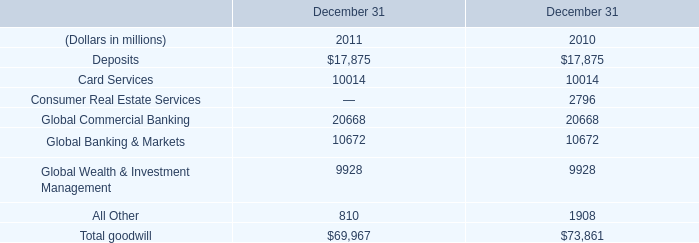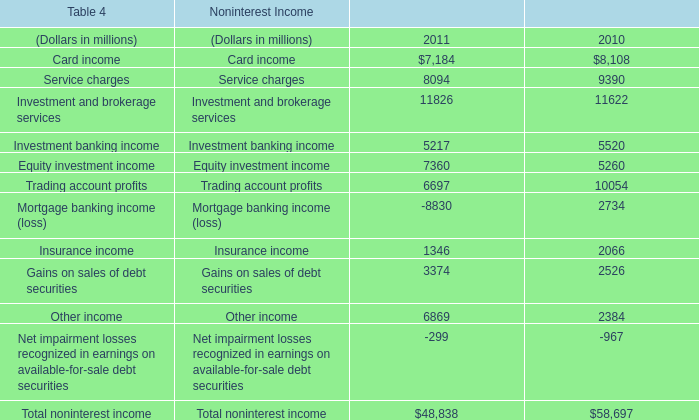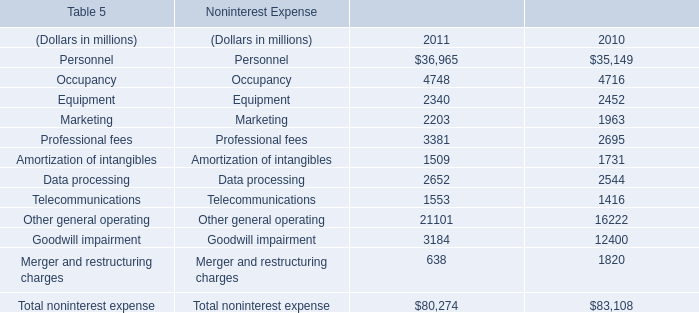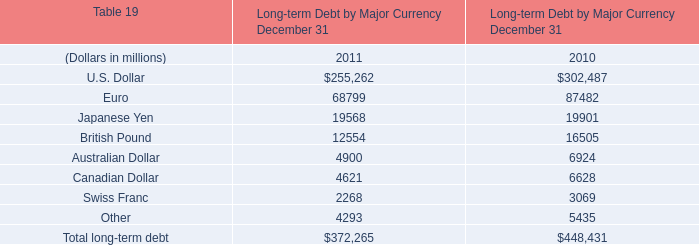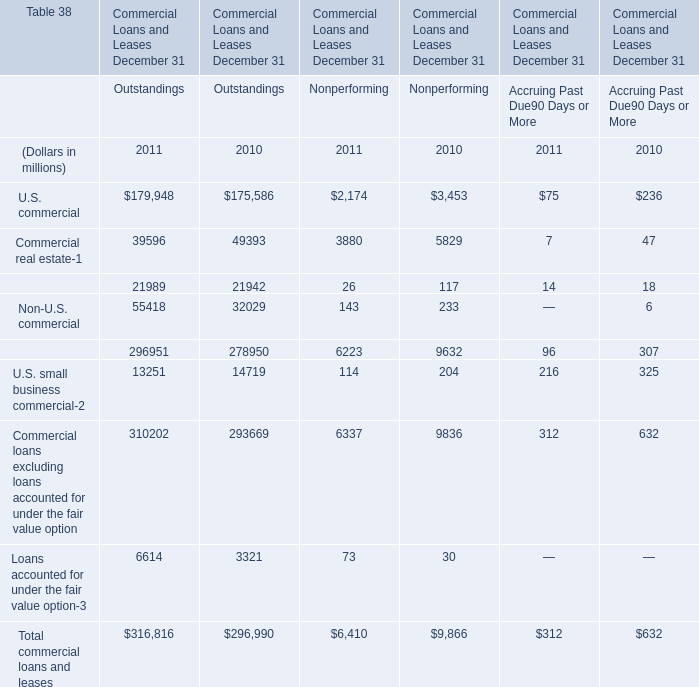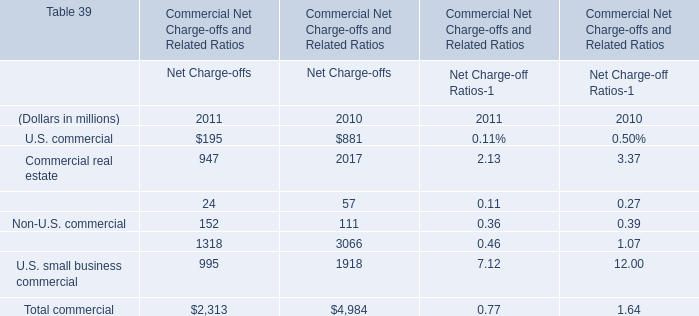If Non-U.S. commercial in terms of Net Charge-offs develops with the same growth rate in 2011, what will it reach in 2012? (in dollars in millions) 
Computations: (152 * (1 + ((152 - 111) / 111)))
Answer: 208.14414. 